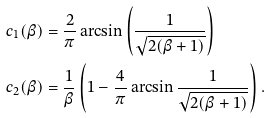Convert formula to latex. <formula><loc_0><loc_0><loc_500><loc_500>& c _ { 1 } ( \beta ) = \frac { 2 } { \pi } \arcsin \left ( { \frac { 1 } { { \sqrt { 2 ( \beta + 1 ) } } } } \right ) \\ & c _ { 2 } ( \beta ) = \frac { 1 } { \beta } \left ( { 1 - \frac { 4 } { \pi } \arcsin \frac { 1 } { { \sqrt { 2 ( \beta + 1 ) } } } } \right ) .</formula> 